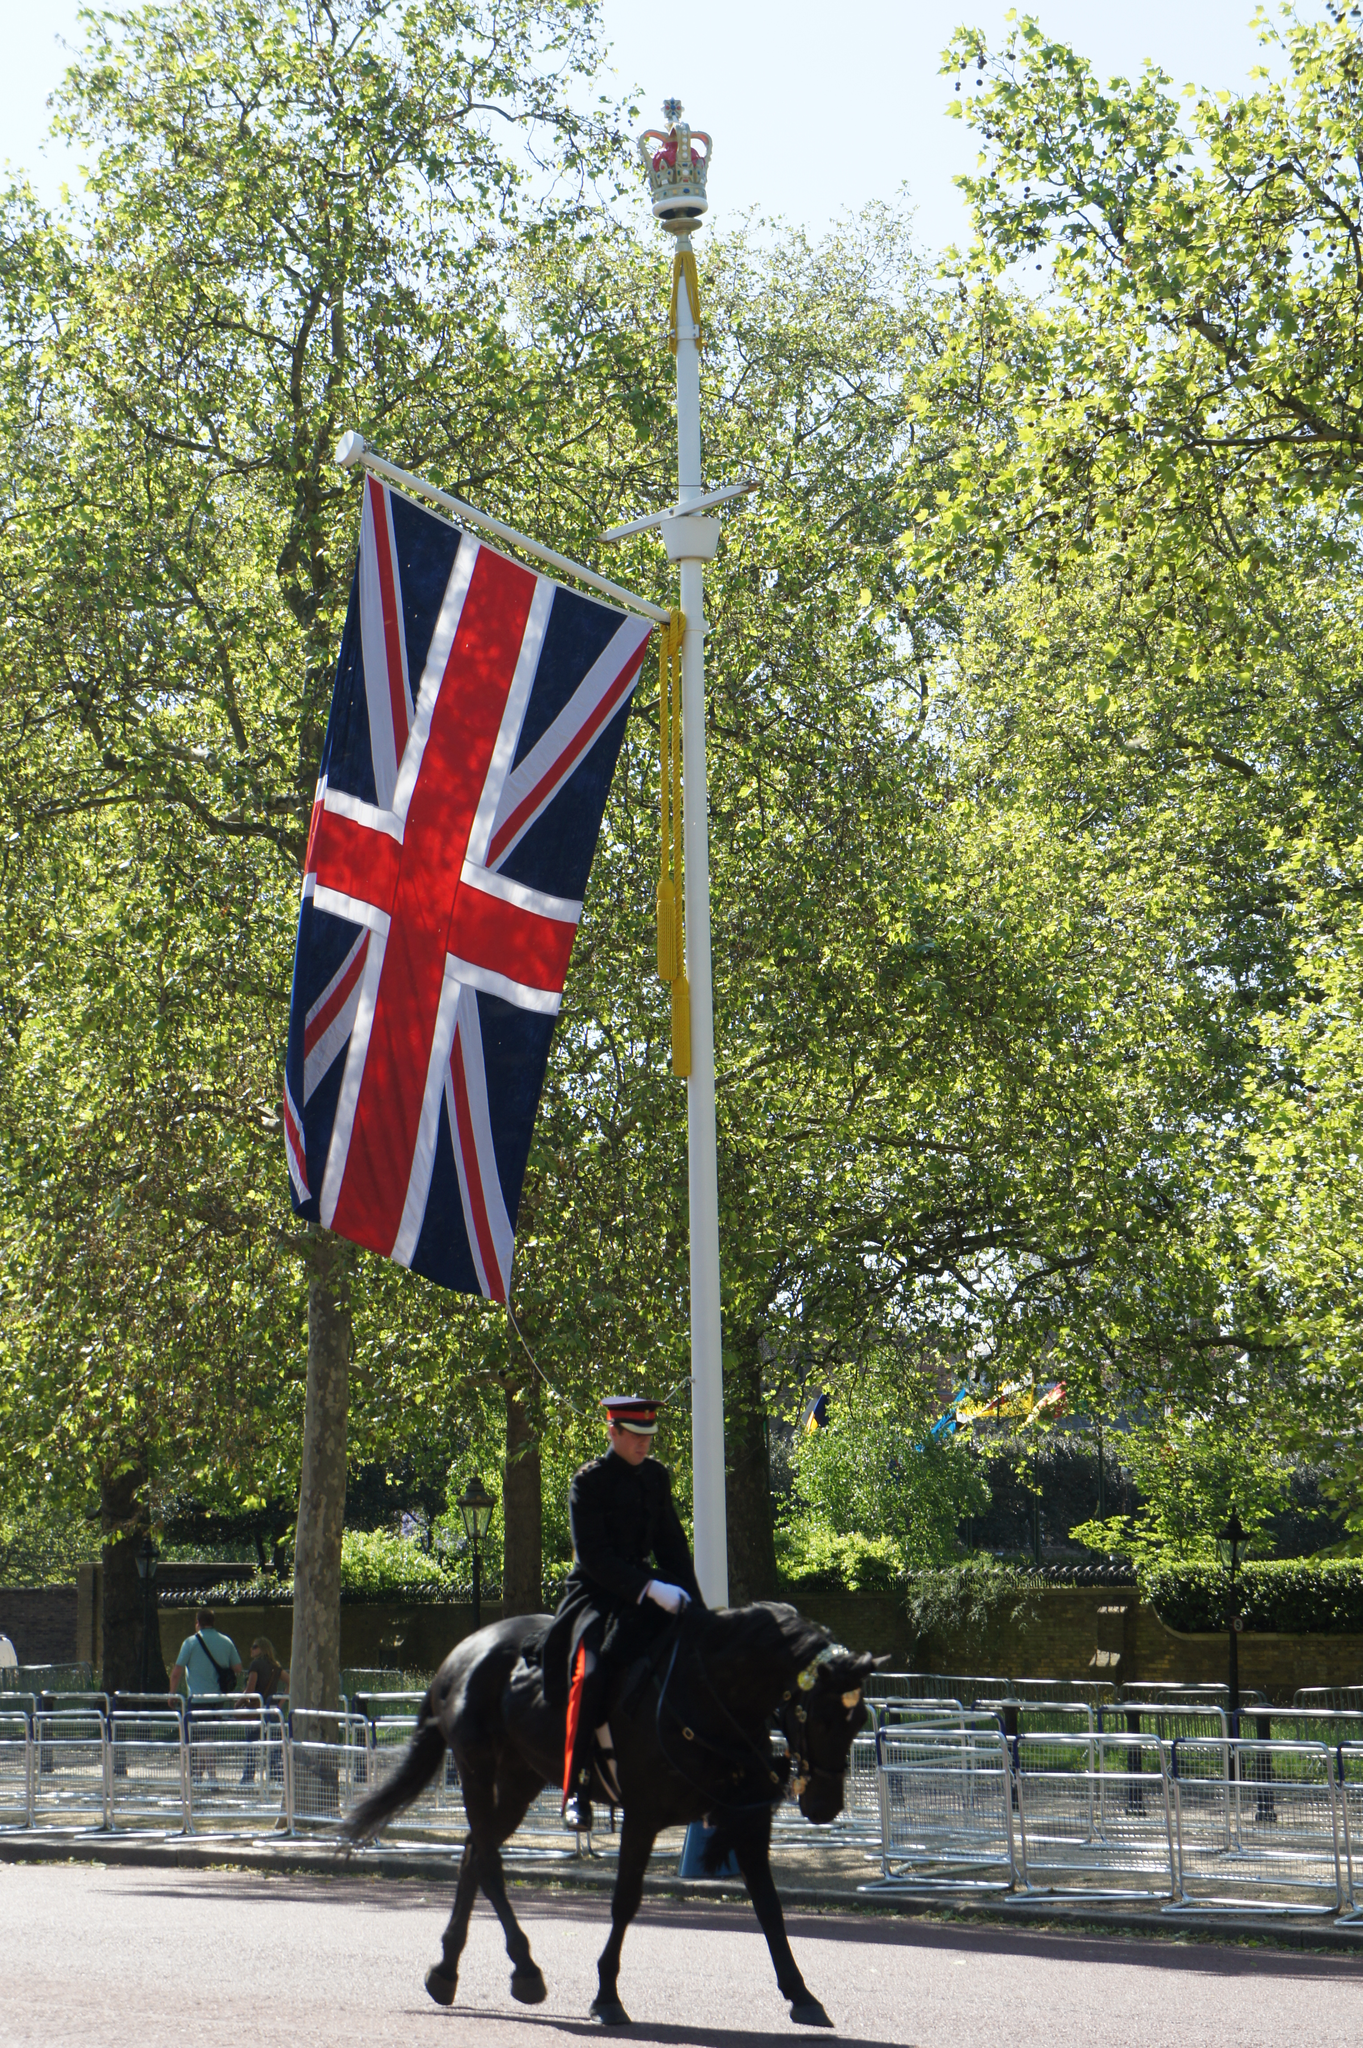How would you summarize this image in a sentence or two? In this picture in the center there is man riding a horse and there is a pole and on the pole there is a flag. In the background there is a fence, there are trees and there is a person and there is a wall. 